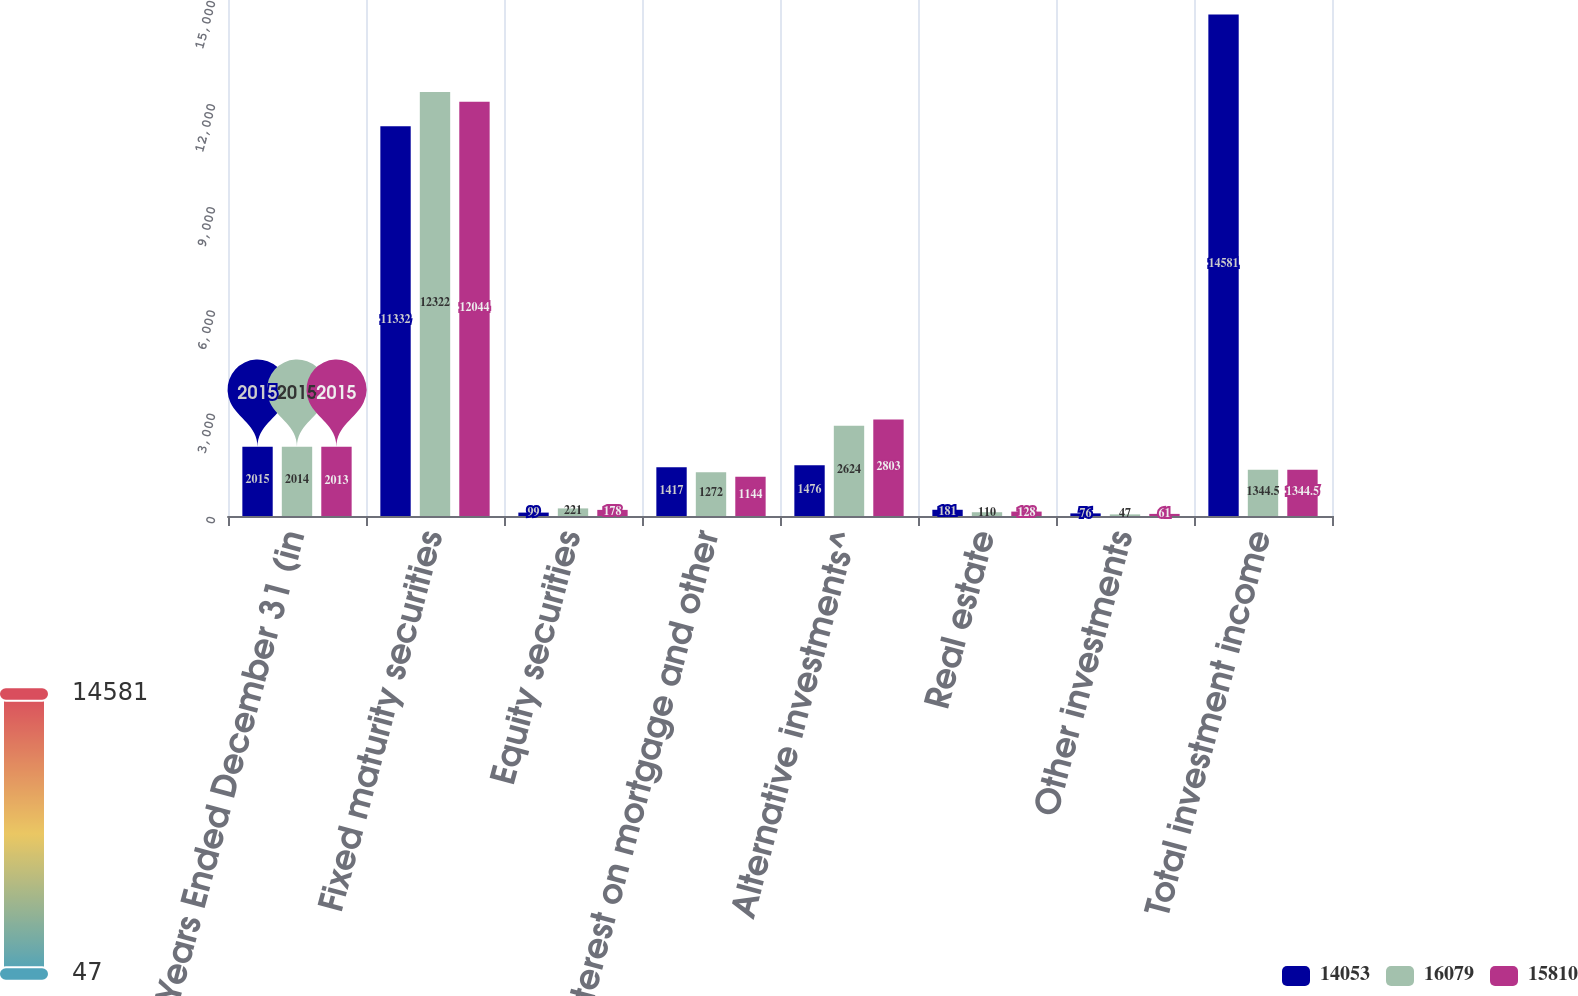Convert chart. <chart><loc_0><loc_0><loc_500><loc_500><stacked_bar_chart><ecel><fcel>Years Ended December 31 (in<fcel>Fixed maturity securities<fcel>Equity securities<fcel>Interest on mortgage and other<fcel>Alternative investments^<fcel>Real estate<fcel>Other investments<fcel>Total investment income<nl><fcel>14053<fcel>2015<fcel>11332<fcel>99<fcel>1417<fcel>1476<fcel>181<fcel>76<fcel>14581<nl><fcel>16079<fcel>2014<fcel>12322<fcel>221<fcel>1272<fcel>2624<fcel>110<fcel>47<fcel>1344.5<nl><fcel>15810<fcel>2013<fcel>12044<fcel>178<fcel>1144<fcel>2803<fcel>128<fcel>61<fcel>1344.5<nl></chart> 